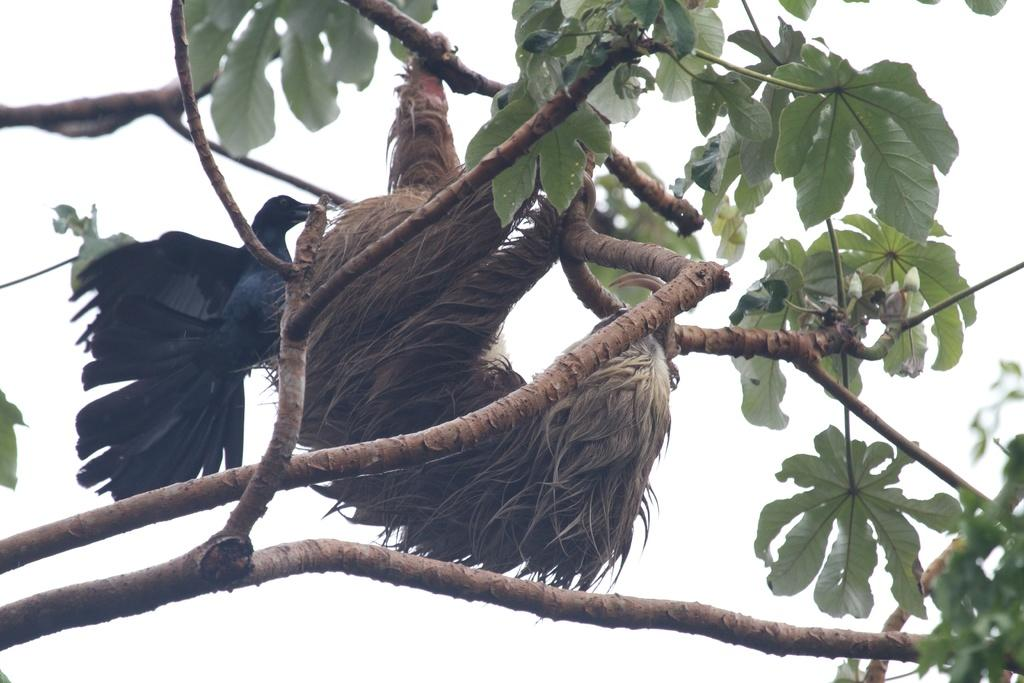What type of bird can be seen in the image? There is a black color bird in the image. Can you describe the other animal present in the image? There is another animal on the tree in the image. What is the taste of the bird in the image? Birds do not have a taste, as they are living creatures and not food items. How many units of the other animal are present in the image? There is only one other animal present in the image, so it cannot be described as a unit. 